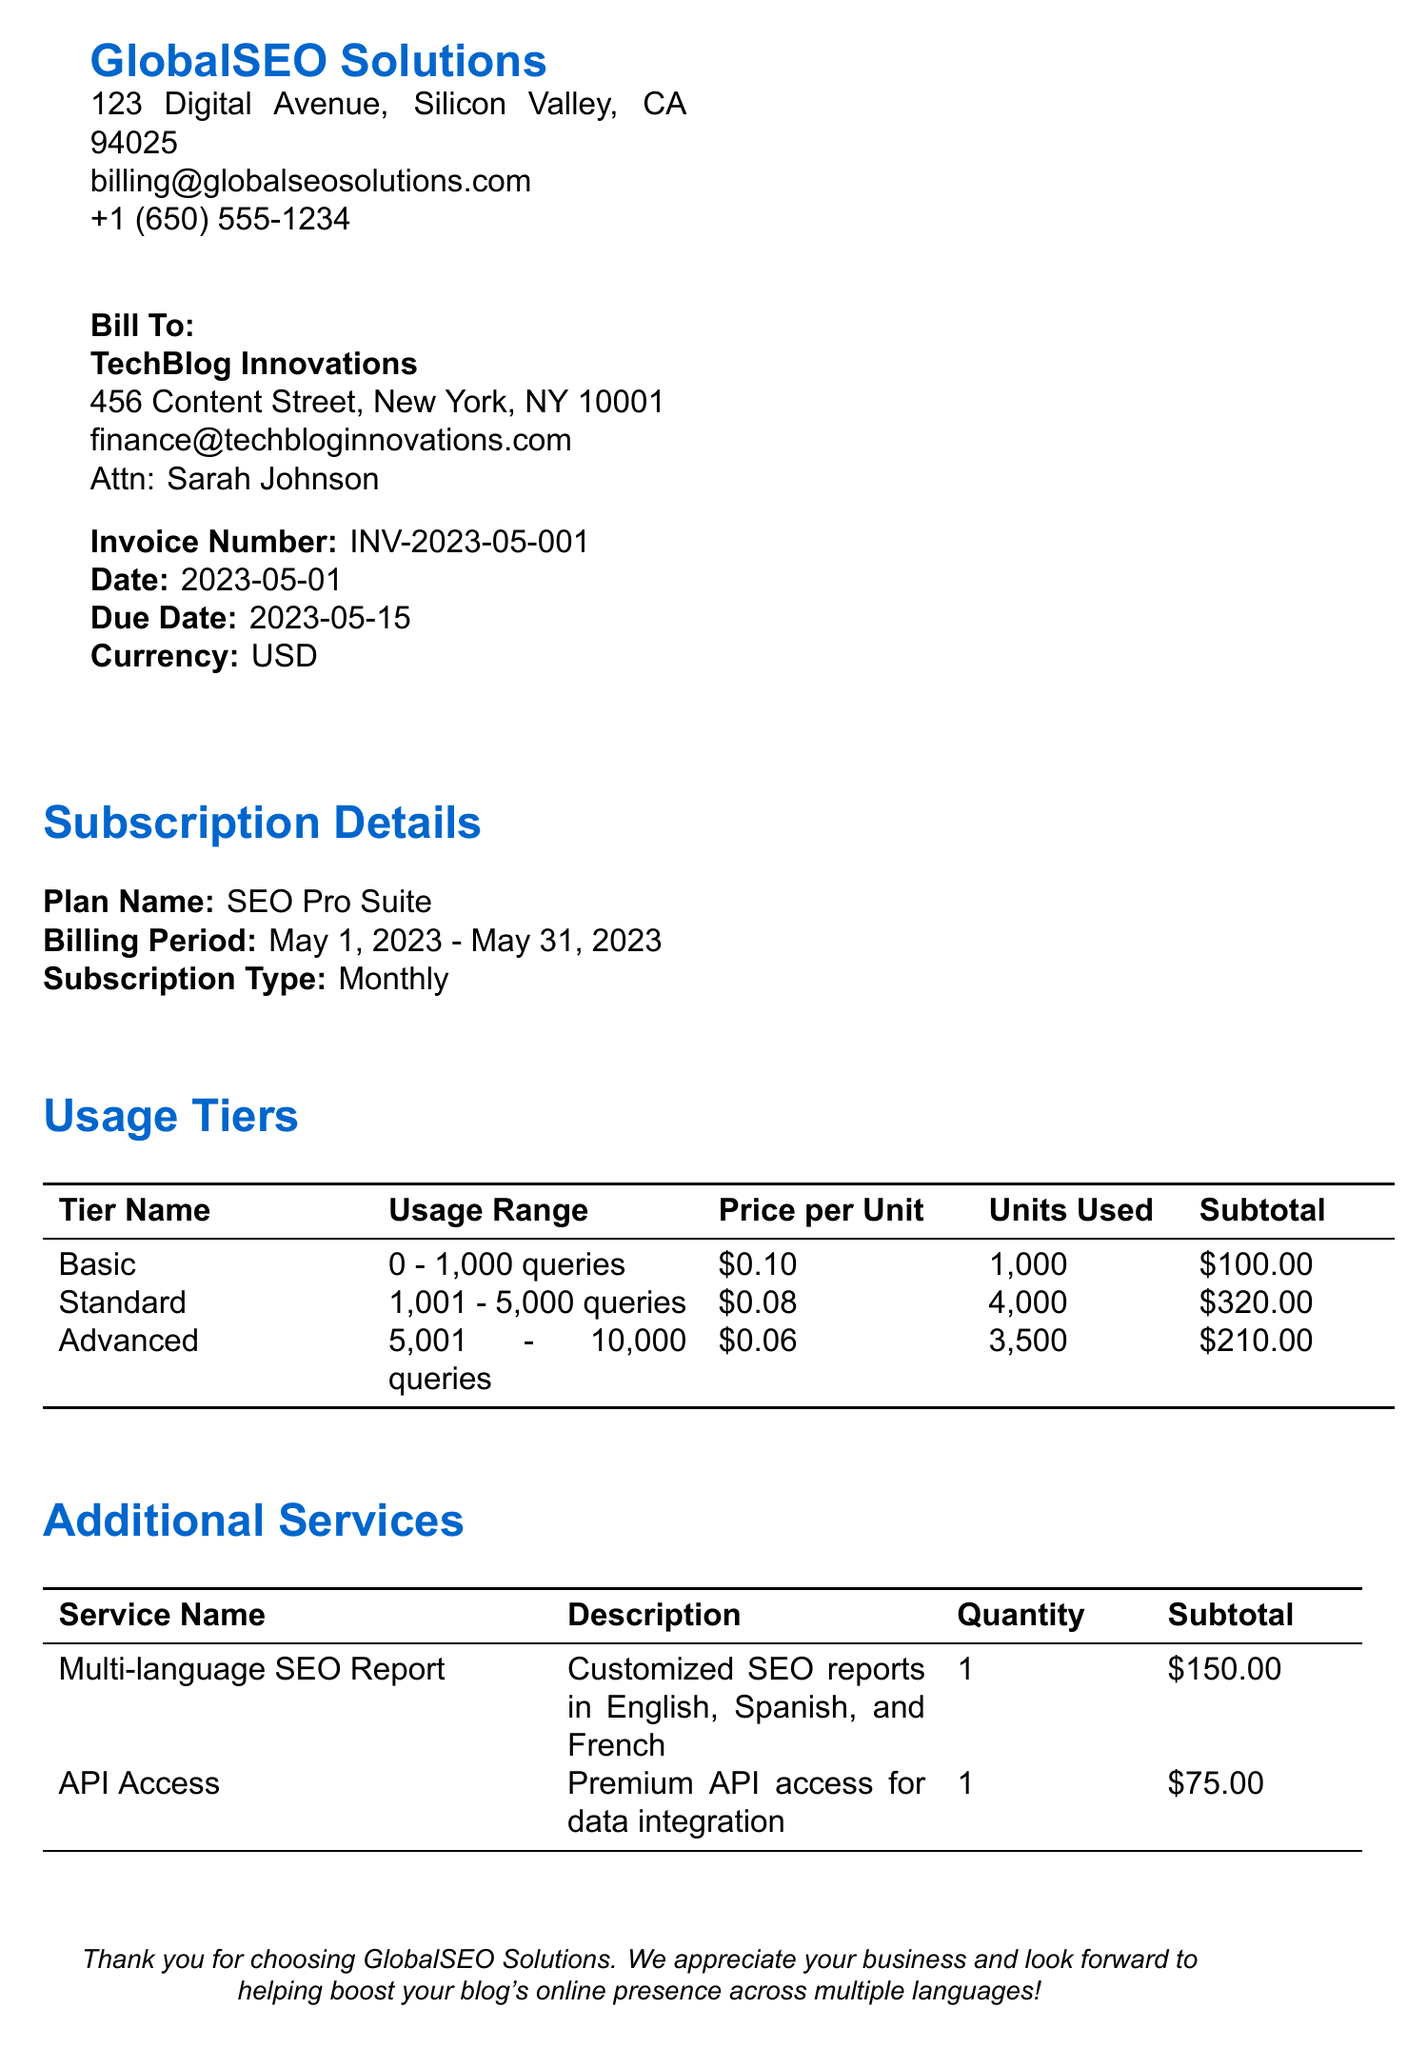what is the invoice number? The invoice number is found in the invoice details section of the document.
Answer: INV-2023-05-001 who is the contact person for the client? The contact person is provided in the client info section of the document.
Answer: Sarah Johnson what is the due date for the invoice? The due date is mentioned in the invoice details section.
Answer: 2023-05-15 how many units were used in the Advanced tier? The units used in the Advanced tier is specified in the usage tiers table.
Answer: 3500 what is the subtotal before applying the discount? The subtotal is calculated by summing all the subtotals from the usage tiers and additional services.
Answer: 855.00 what percentage is the tax rate applied to the total? The tax rate is outlined in the summary section of the document.
Answer: 8.875% what is the total amount due after discount and tax? The total amount is the final value shown in the summary after applying the discount and tax.
Answer: 884.34 what are the accepted payment methods? The payment options section lists the methods for making payments.
Answer: Credit Card, Bank Transfer, PayPal what type of subscription is listed in the document? The subscription type is defined in the subscription details section.
Answer: Monthly 